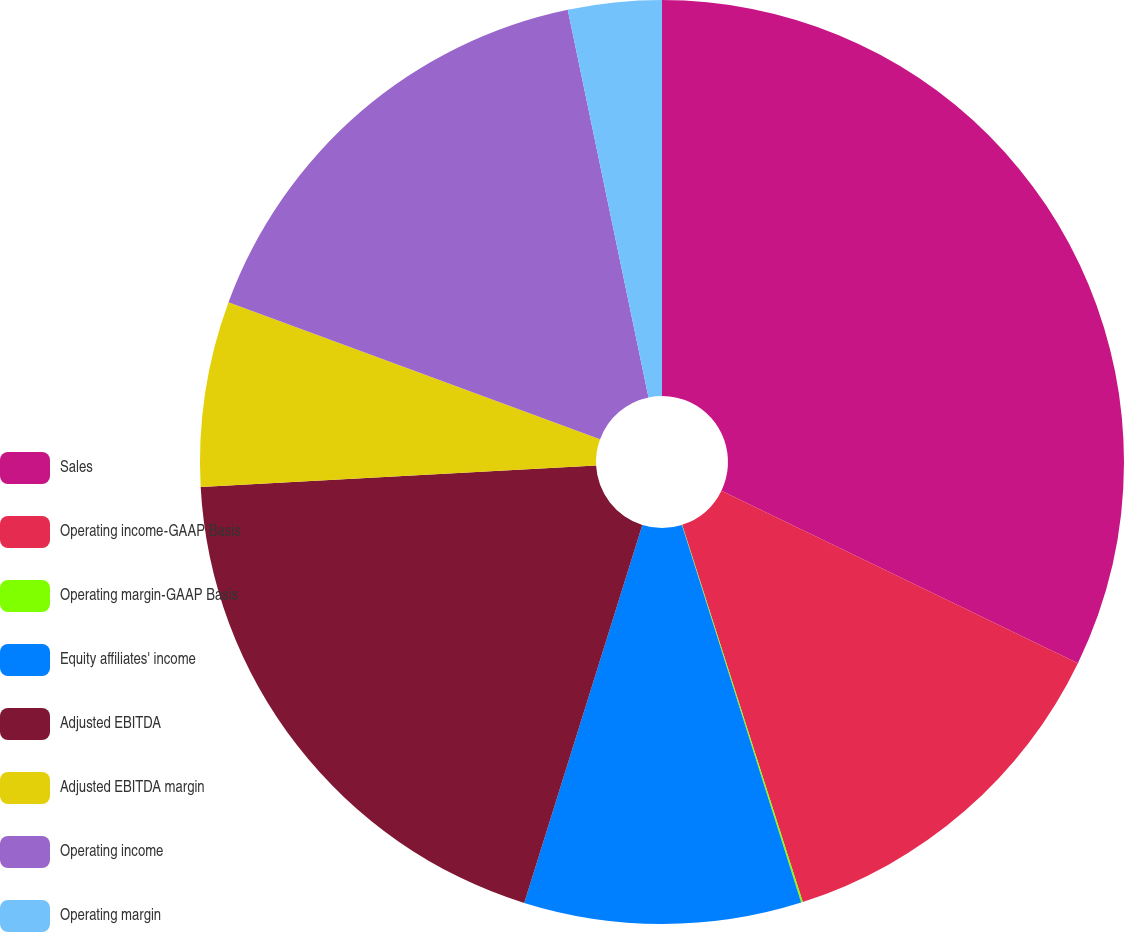Convert chart to OTSL. <chart><loc_0><loc_0><loc_500><loc_500><pie_chart><fcel>Sales<fcel>Operating income-GAAP Basis<fcel>Operating margin-GAAP Basis<fcel>Equity affiliates' income<fcel>Adjusted EBITDA<fcel>Adjusted EBITDA margin<fcel>Operating income<fcel>Operating margin<nl><fcel>32.17%<fcel>12.9%<fcel>0.06%<fcel>9.69%<fcel>19.32%<fcel>6.48%<fcel>16.11%<fcel>3.27%<nl></chart> 